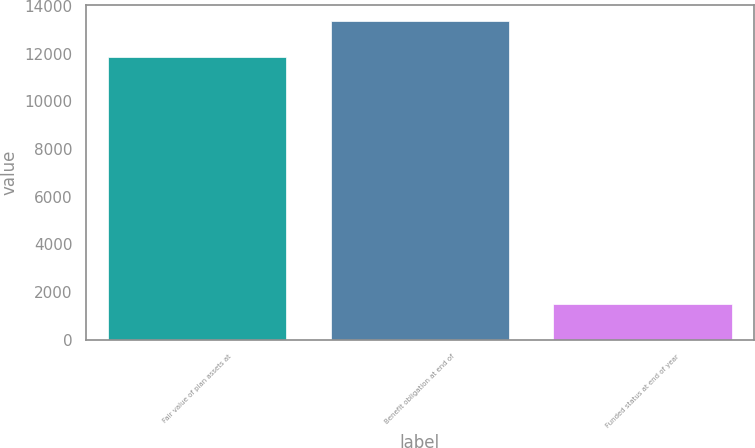Convert chart. <chart><loc_0><loc_0><loc_500><loc_500><bar_chart><fcel>Fair value of plan assets at<fcel>Benefit obligation at end of<fcel>Funded status at end of year<nl><fcel>11850<fcel>13355<fcel>1505<nl></chart> 